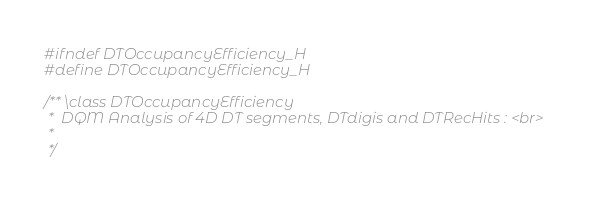<code> <loc_0><loc_0><loc_500><loc_500><_C_>#ifndef DTOccupancyEfficiency_H
#define DTOccupancyEfficiency_H

/** \class DTOccupancyEfficiency
 *  DQM Analysis of 4D DT segments, DTdigis and DTRecHits : <br>
 *   
 */
</code> 